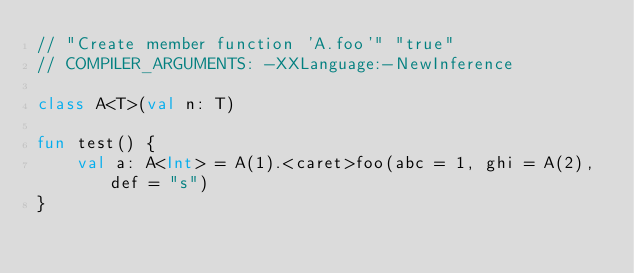<code> <loc_0><loc_0><loc_500><loc_500><_Kotlin_>// "Create member function 'A.foo'" "true"
// COMPILER_ARGUMENTS: -XXLanguage:-NewInference

class A<T>(val n: T)

fun test() {
    val a: A<Int> = A(1).<caret>foo(abc = 1, ghi = A(2), def = "s")
}</code> 